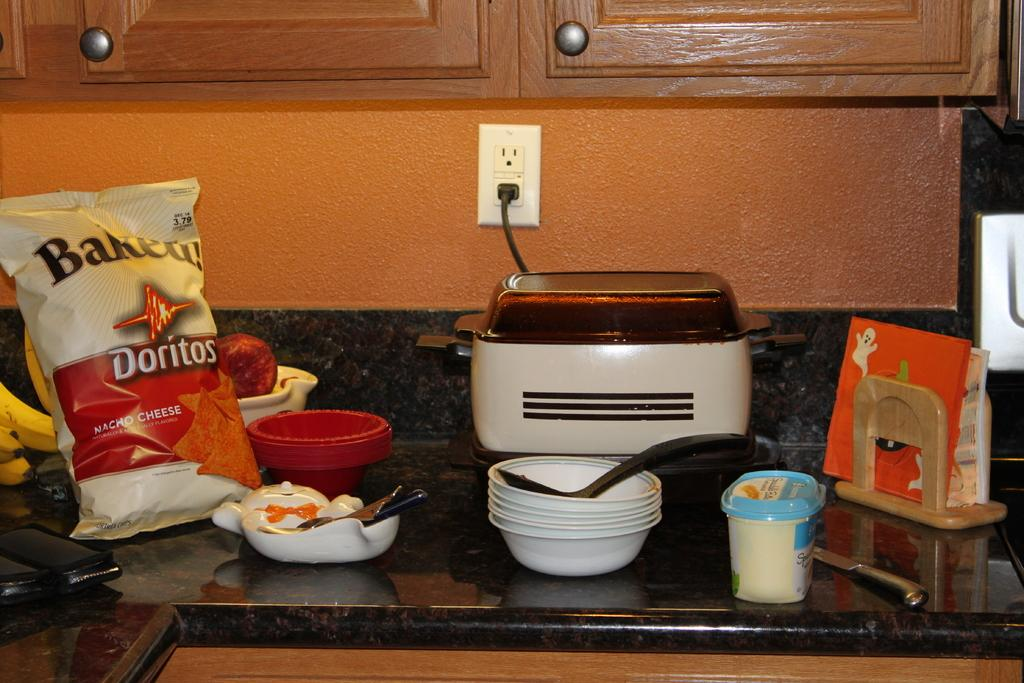Provide a one-sentence caption for the provided image. A kitchen counter top covered in bowls, napkins, and a bag of Baked Doritos. 